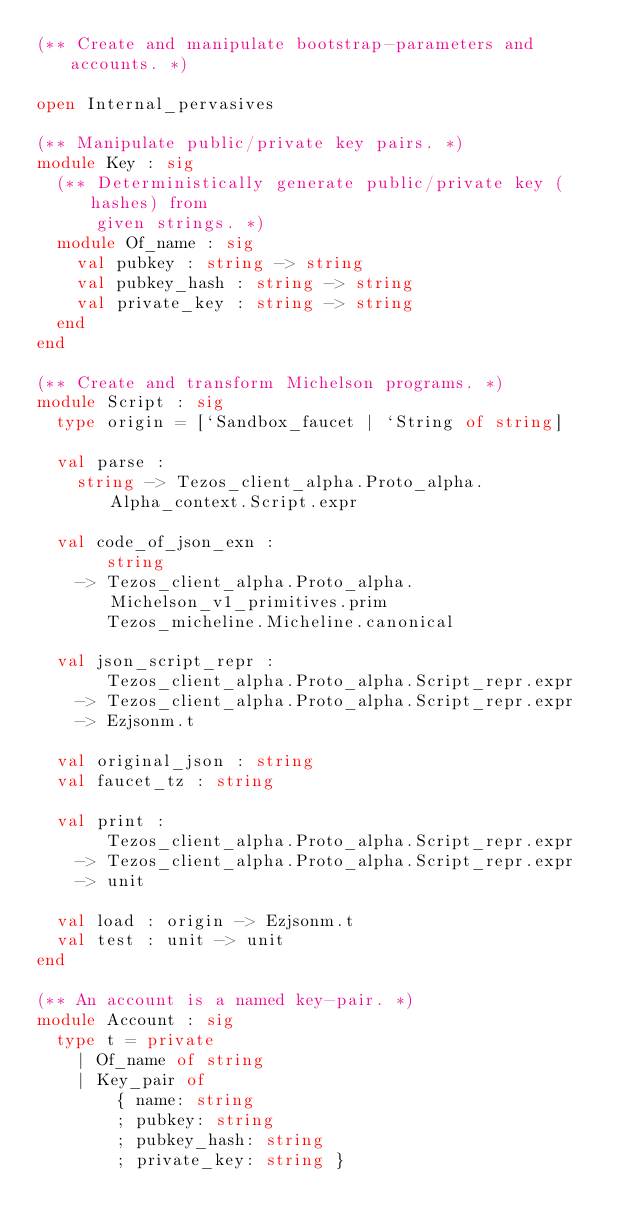<code> <loc_0><loc_0><loc_500><loc_500><_OCaml_>(** Create and manipulate bootstrap-parameters and accounts. *)

open Internal_pervasives

(** Manipulate public/private key pairs. *)
module Key : sig
  (** Deterministically generate public/private key (hashes) from
      given strings. *)
  module Of_name : sig
    val pubkey : string -> string
    val pubkey_hash : string -> string
    val private_key : string -> string
  end
end

(** Create and transform Michelson programs. *)
module Script : sig
  type origin = [`Sandbox_faucet | `String of string]

  val parse :
    string -> Tezos_client_alpha.Proto_alpha.Alpha_context.Script.expr

  val code_of_json_exn :
       string
    -> Tezos_client_alpha.Proto_alpha.Michelson_v1_primitives.prim
       Tezos_micheline.Micheline.canonical

  val json_script_repr :
       Tezos_client_alpha.Proto_alpha.Script_repr.expr
    -> Tezos_client_alpha.Proto_alpha.Script_repr.expr
    -> Ezjsonm.t

  val original_json : string
  val faucet_tz : string

  val print :
       Tezos_client_alpha.Proto_alpha.Script_repr.expr
    -> Tezos_client_alpha.Proto_alpha.Script_repr.expr
    -> unit

  val load : origin -> Ezjsonm.t
  val test : unit -> unit
end

(** An account is a named key-pair. *)
module Account : sig
  type t = private
    | Of_name of string
    | Key_pair of
        { name: string
        ; pubkey: string
        ; pubkey_hash: string
        ; private_key: string }
</code> 